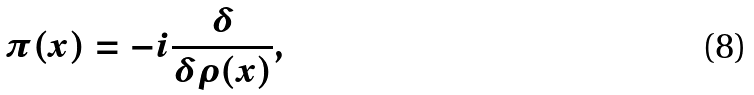<formula> <loc_0><loc_0><loc_500><loc_500>\pi ( x ) = - i \frac { \delta } { \delta \rho ( x ) } ,</formula> 